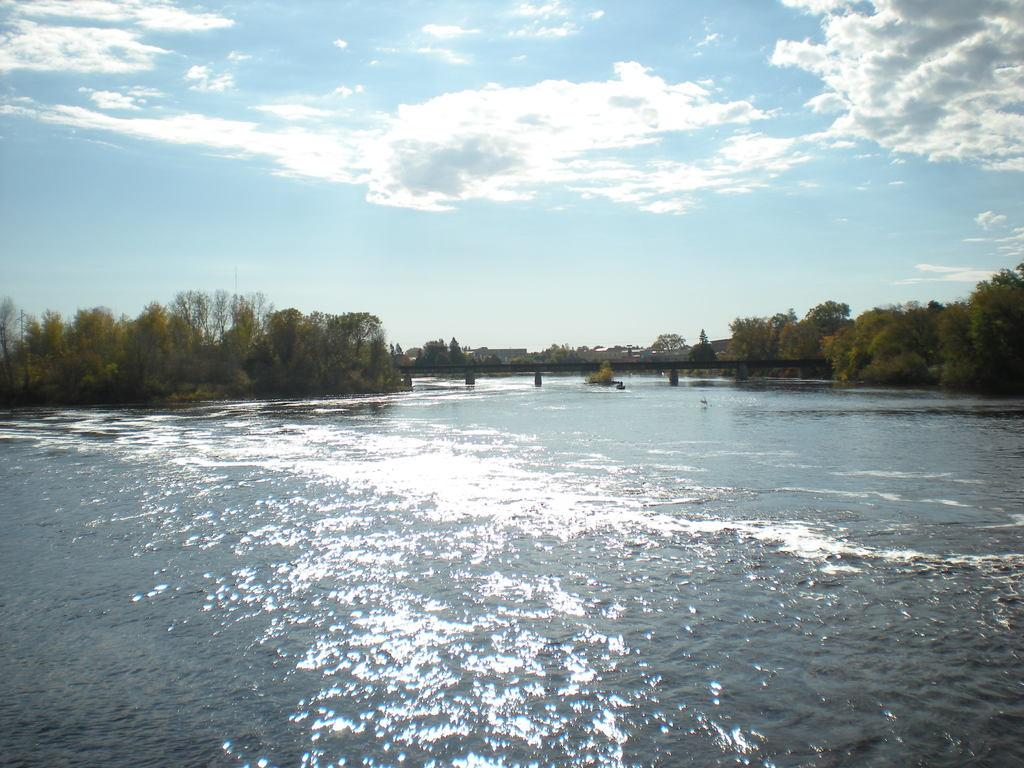What is the main feature of the image? The center of the image contains the sky. What can be seen in the sky? Clouds are visible in the sky. What type of natural elements are present in the image? Trees and water are present in the image. What man-made structure is visible in the image? A bridge is present in the image. Are there any other objects or features in the image? Yes, there are other objects in the image. What type of pencil is the father using to work in the image? There is no pencil, father, or work being depicted in the image. 